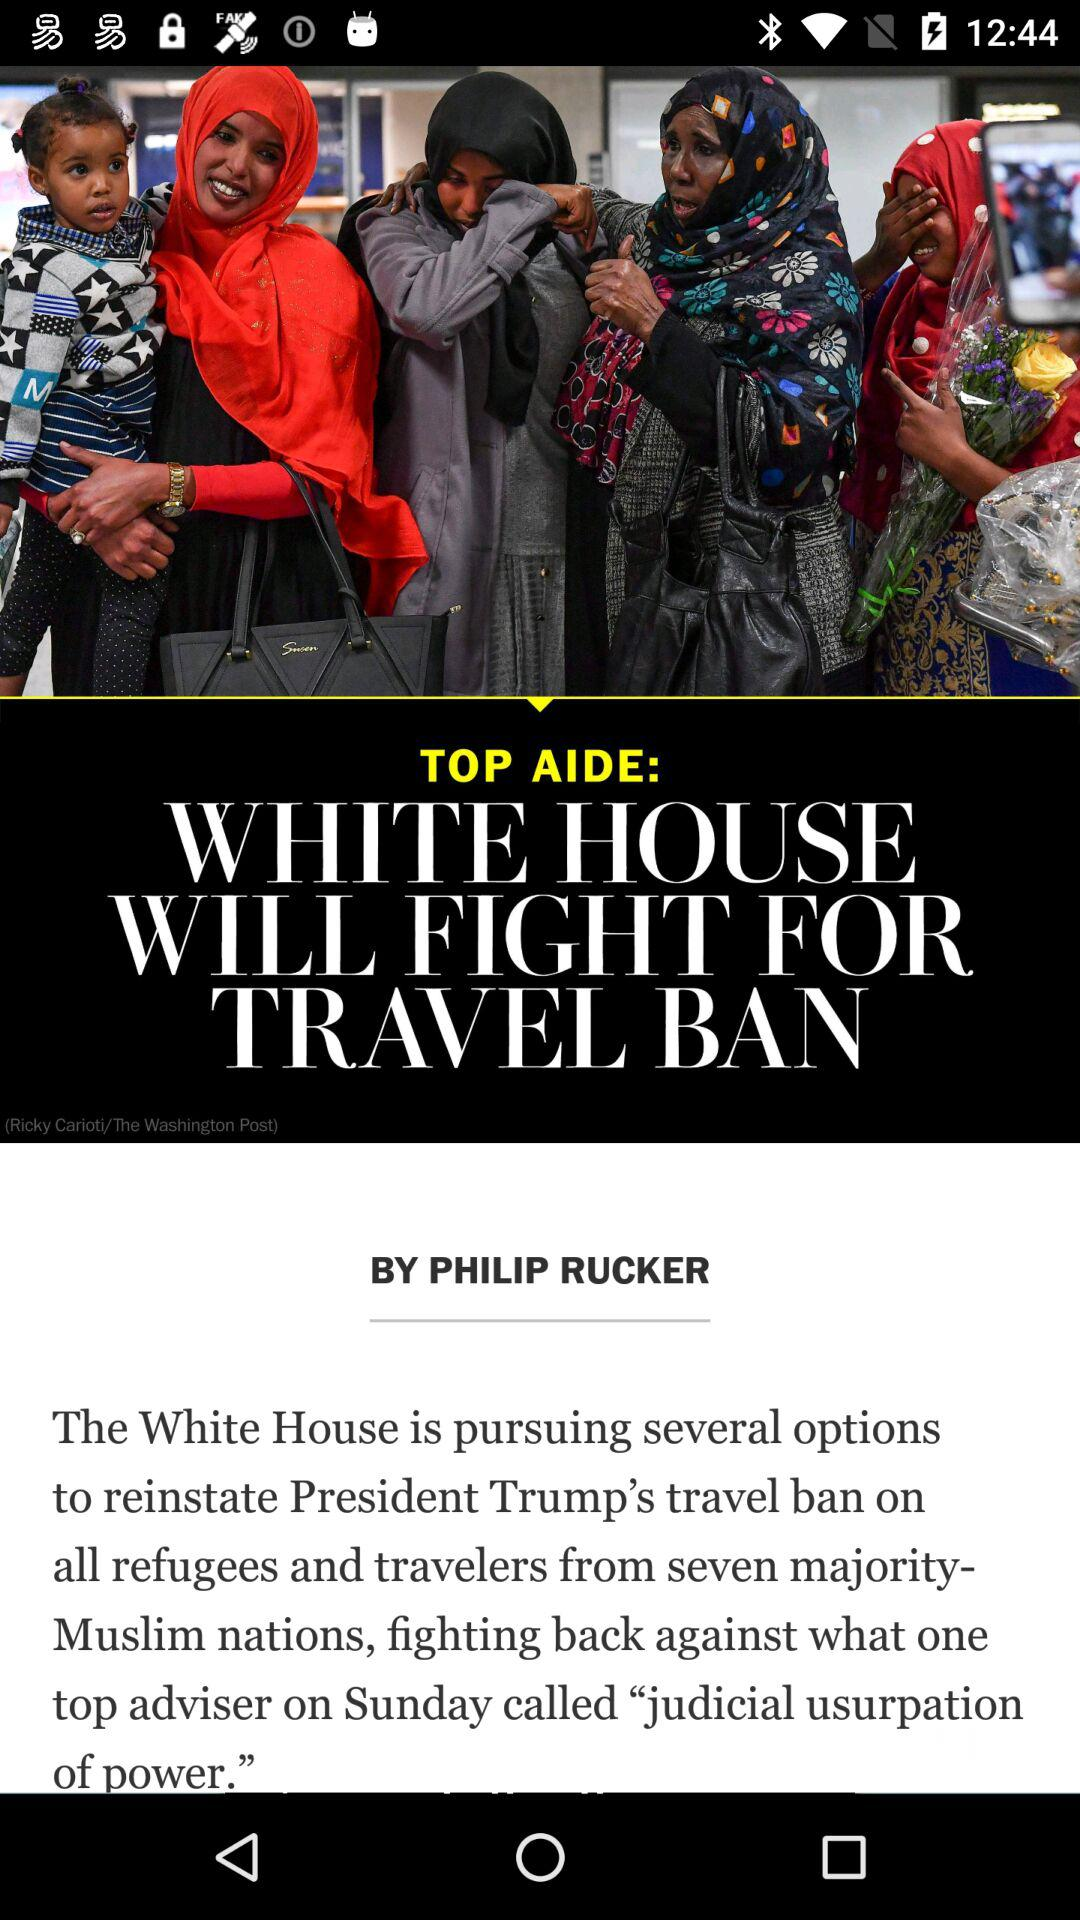What is the headline of the article? The headline of the article is "WHITE HOUSE WILL FIGHT FOR TRAVEL BAN". 